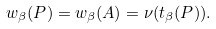Convert formula to latex. <formula><loc_0><loc_0><loc_500><loc_500>w _ { \beta } ( P ) = w _ { \beta } ( A ) = \nu ( t _ { \beta } ( P ) ) .</formula> 